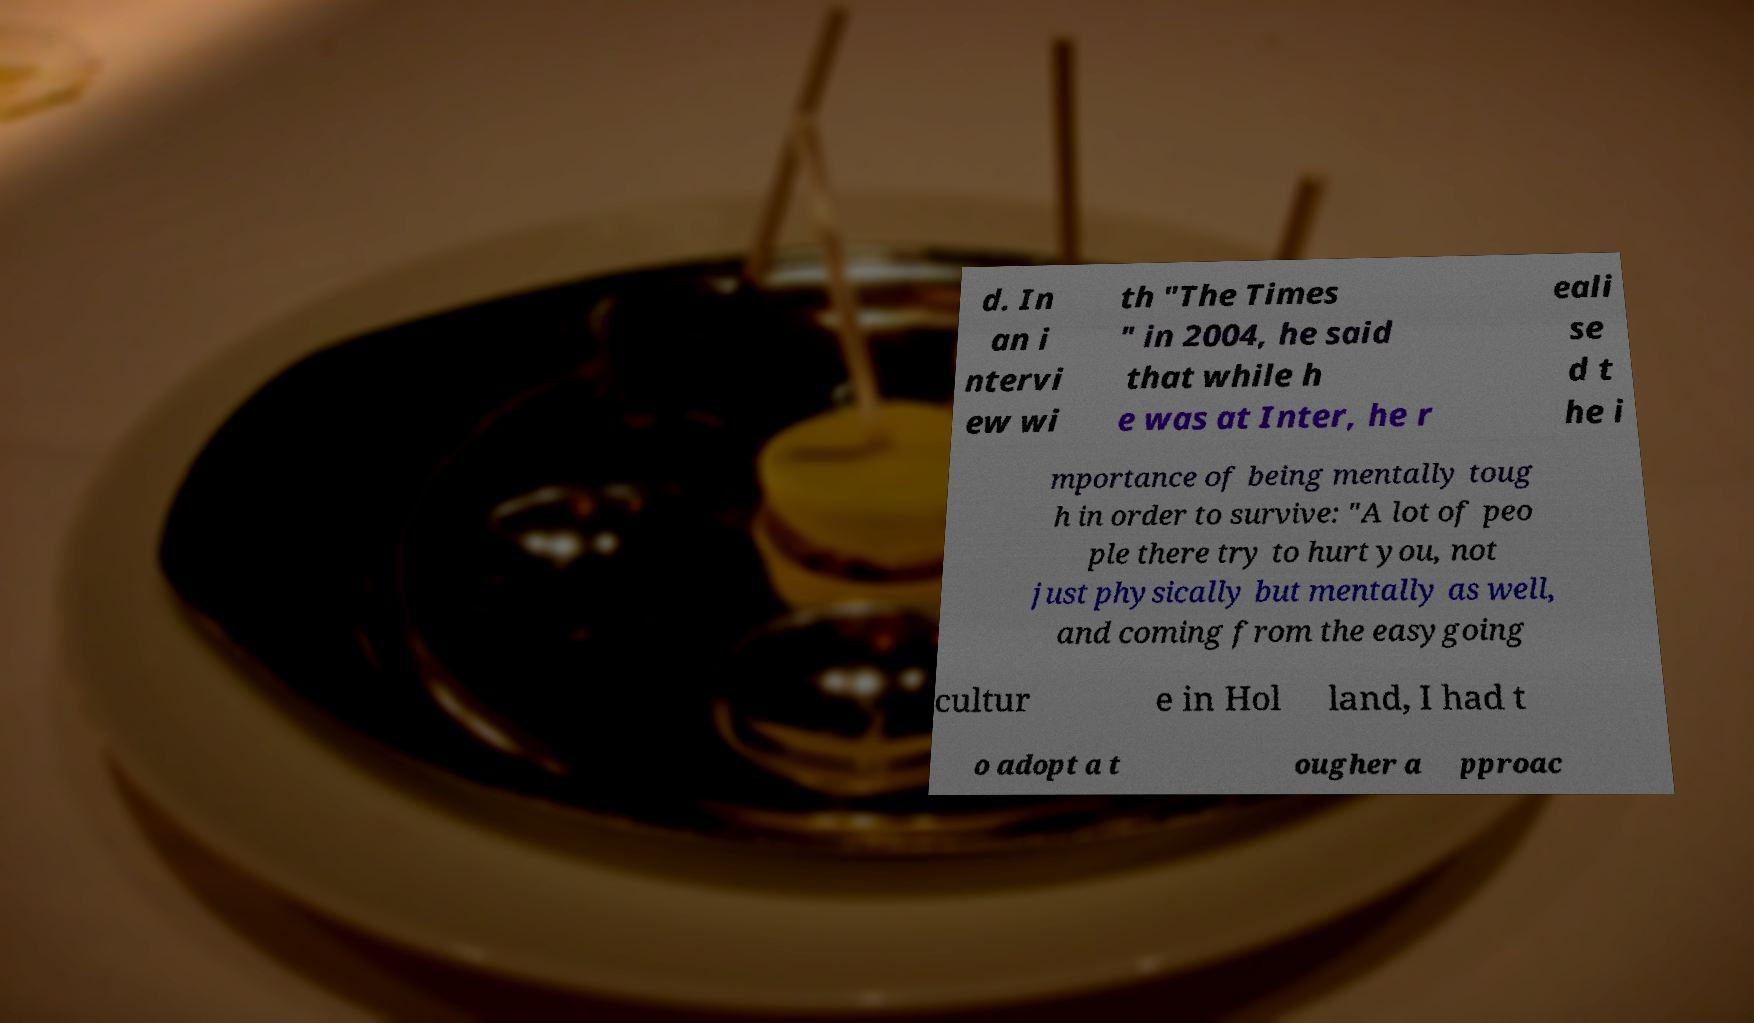Could you extract and type out the text from this image? d. In an i ntervi ew wi th "The Times " in 2004, he said that while h e was at Inter, he r eali se d t he i mportance of being mentally toug h in order to survive: "A lot of peo ple there try to hurt you, not just physically but mentally as well, and coming from the easygoing cultur e in Hol land, I had t o adopt a t ougher a pproac 